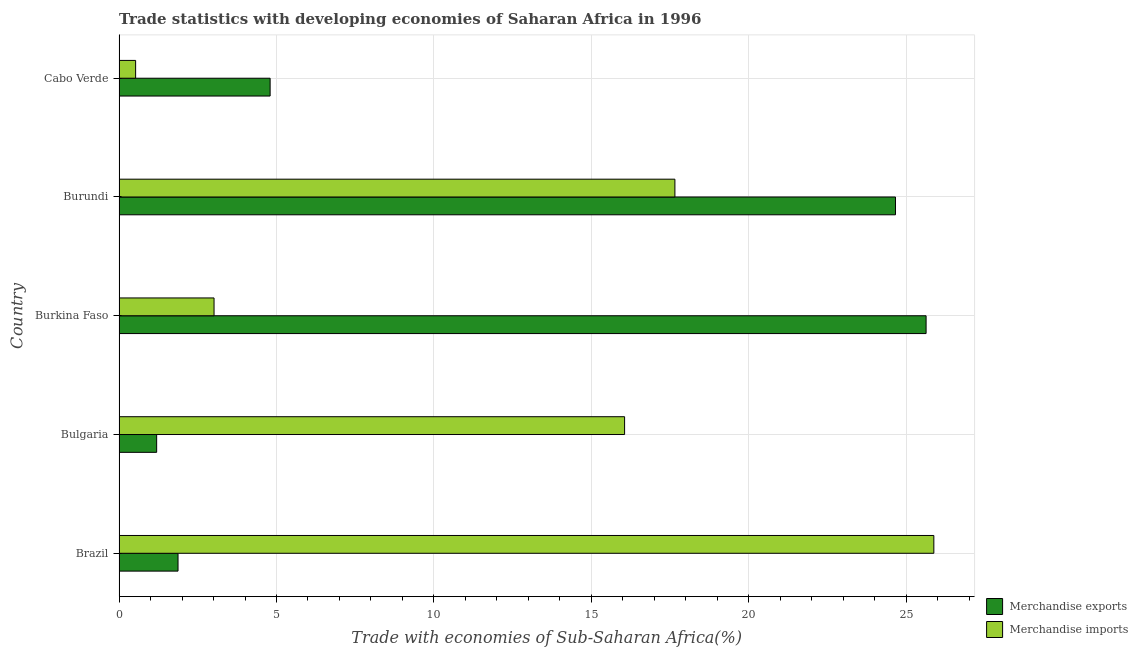How many different coloured bars are there?
Your answer should be compact. 2. What is the label of the 2nd group of bars from the top?
Your response must be concise. Burundi. What is the merchandise imports in Burundi?
Keep it short and to the point. 17.65. Across all countries, what is the maximum merchandise imports?
Keep it short and to the point. 25.87. Across all countries, what is the minimum merchandise exports?
Make the answer very short. 1.19. In which country was the merchandise exports maximum?
Provide a succinct answer. Burkina Faso. In which country was the merchandise imports minimum?
Offer a very short reply. Cabo Verde. What is the total merchandise imports in the graph?
Make the answer very short. 63.12. What is the difference between the merchandise imports in Burkina Faso and that in Cabo Verde?
Provide a succinct answer. 2.49. What is the difference between the merchandise imports in Burundi and the merchandise exports in Cabo Verde?
Keep it short and to the point. 12.85. What is the average merchandise exports per country?
Provide a succinct answer. 11.63. What is the difference between the merchandise imports and merchandise exports in Burkina Faso?
Your response must be concise. -22.61. In how many countries, is the merchandise exports greater than 4 %?
Give a very brief answer. 3. What is the ratio of the merchandise imports in Brazil to that in Burkina Faso?
Offer a terse response. 8.58. What is the difference between the highest and the second highest merchandise imports?
Ensure brevity in your answer.  8.22. What is the difference between the highest and the lowest merchandise exports?
Offer a very short reply. 24.43. In how many countries, is the merchandise imports greater than the average merchandise imports taken over all countries?
Provide a succinct answer. 3. How many bars are there?
Provide a short and direct response. 10. Are all the bars in the graph horizontal?
Ensure brevity in your answer.  Yes. Are the values on the major ticks of X-axis written in scientific E-notation?
Your answer should be compact. No. Does the graph contain any zero values?
Ensure brevity in your answer.  No. How are the legend labels stacked?
Ensure brevity in your answer.  Vertical. What is the title of the graph?
Your answer should be very brief. Trade statistics with developing economies of Saharan Africa in 1996. Does "Under-5(male)" appear as one of the legend labels in the graph?
Provide a short and direct response. No. What is the label or title of the X-axis?
Give a very brief answer. Trade with economies of Sub-Saharan Africa(%). What is the label or title of the Y-axis?
Offer a terse response. Country. What is the Trade with economies of Sub-Saharan Africa(%) in Merchandise exports in Brazil?
Your answer should be compact. 1.87. What is the Trade with economies of Sub-Saharan Africa(%) of Merchandise imports in Brazil?
Provide a short and direct response. 25.87. What is the Trade with economies of Sub-Saharan Africa(%) of Merchandise exports in Bulgaria?
Keep it short and to the point. 1.19. What is the Trade with economies of Sub-Saharan Africa(%) in Merchandise imports in Bulgaria?
Your response must be concise. 16.05. What is the Trade with economies of Sub-Saharan Africa(%) of Merchandise exports in Burkina Faso?
Give a very brief answer. 25.63. What is the Trade with economies of Sub-Saharan Africa(%) in Merchandise imports in Burkina Faso?
Make the answer very short. 3.02. What is the Trade with economies of Sub-Saharan Africa(%) in Merchandise exports in Burundi?
Keep it short and to the point. 24.66. What is the Trade with economies of Sub-Saharan Africa(%) of Merchandise imports in Burundi?
Keep it short and to the point. 17.65. What is the Trade with economies of Sub-Saharan Africa(%) in Merchandise exports in Cabo Verde?
Your answer should be compact. 4.8. What is the Trade with economies of Sub-Saharan Africa(%) of Merchandise imports in Cabo Verde?
Provide a succinct answer. 0.53. Across all countries, what is the maximum Trade with economies of Sub-Saharan Africa(%) in Merchandise exports?
Offer a very short reply. 25.63. Across all countries, what is the maximum Trade with economies of Sub-Saharan Africa(%) in Merchandise imports?
Offer a very short reply. 25.87. Across all countries, what is the minimum Trade with economies of Sub-Saharan Africa(%) of Merchandise exports?
Ensure brevity in your answer.  1.19. Across all countries, what is the minimum Trade with economies of Sub-Saharan Africa(%) in Merchandise imports?
Your answer should be very brief. 0.53. What is the total Trade with economies of Sub-Saharan Africa(%) in Merchandise exports in the graph?
Ensure brevity in your answer.  58.15. What is the total Trade with economies of Sub-Saharan Africa(%) of Merchandise imports in the graph?
Make the answer very short. 63.12. What is the difference between the Trade with economies of Sub-Saharan Africa(%) in Merchandise exports in Brazil and that in Bulgaria?
Provide a short and direct response. 0.68. What is the difference between the Trade with economies of Sub-Saharan Africa(%) of Merchandise imports in Brazil and that in Bulgaria?
Your response must be concise. 9.82. What is the difference between the Trade with economies of Sub-Saharan Africa(%) of Merchandise exports in Brazil and that in Burkina Faso?
Offer a very short reply. -23.76. What is the difference between the Trade with economies of Sub-Saharan Africa(%) in Merchandise imports in Brazil and that in Burkina Faso?
Make the answer very short. 22.86. What is the difference between the Trade with economies of Sub-Saharan Africa(%) in Merchandise exports in Brazil and that in Burundi?
Your answer should be compact. -22.78. What is the difference between the Trade with economies of Sub-Saharan Africa(%) in Merchandise imports in Brazil and that in Burundi?
Your answer should be compact. 8.22. What is the difference between the Trade with economies of Sub-Saharan Africa(%) of Merchandise exports in Brazil and that in Cabo Verde?
Your answer should be very brief. -2.92. What is the difference between the Trade with economies of Sub-Saharan Africa(%) of Merchandise imports in Brazil and that in Cabo Verde?
Give a very brief answer. 25.35. What is the difference between the Trade with economies of Sub-Saharan Africa(%) in Merchandise exports in Bulgaria and that in Burkina Faso?
Keep it short and to the point. -24.43. What is the difference between the Trade with economies of Sub-Saharan Africa(%) in Merchandise imports in Bulgaria and that in Burkina Faso?
Offer a very short reply. 13.04. What is the difference between the Trade with economies of Sub-Saharan Africa(%) in Merchandise exports in Bulgaria and that in Burundi?
Give a very brief answer. -23.46. What is the difference between the Trade with economies of Sub-Saharan Africa(%) in Merchandise imports in Bulgaria and that in Burundi?
Provide a succinct answer. -1.6. What is the difference between the Trade with economies of Sub-Saharan Africa(%) in Merchandise exports in Bulgaria and that in Cabo Verde?
Offer a terse response. -3.6. What is the difference between the Trade with economies of Sub-Saharan Africa(%) of Merchandise imports in Bulgaria and that in Cabo Verde?
Your answer should be compact. 15.53. What is the difference between the Trade with economies of Sub-Saharan Africa(%) of Merchandise exports in Burkina Faso and that in Burundi?
Ensure brevity in your answer.  0.97. What is the difference between the Trade with economies of Sub-Saharan Africa(%) in Merchandise imports in Burkina Faso and that in Burundi?
Give a very brief answer. -14.64. What is the difference between the Trade with economies of Sub-Saharan Africa(%) in Merchandise exports in Burkina Faso and that in Cabo Verde?
Your answer should be very brief. 20.83. What is the difference between the Trade with economies of Sub-Saharan Africa(%) of Merchandise imports in Burkina Faso and that in Cabo Verde?
Provide a short and direct response. 2.49. What is the difference between the Trade with economies of Sub-Saharan Africa(%) in Merchandise exports in Burundi and that in Cabo Verde?
Your answer should be compact. 19.86. What is the difference between the Trade with economies of Sub-Saharan Africa(%) of Merchandise imports in Burundi and that in Cabo Verde?
Give a very brief answer. 17.13. What is the difference between the Trade with economies of Sub-Saharan Africa(%) of Merchandise exports in Brazil and the Trade with economies of Sub-Saharan Africa(%) of Merchandise imports in Bulgaria?
Ensure brevity in your answer.  -14.18. What is the difference between the Trade with economies of Sub-Saharan Africa(%) in Merchandise exports in Brazil and the Trade with economies of Sub-Saharan Africa(%) in Merchandise imports in Burkina Faso?
Ensure brevity in your answer.  -1.14. What is the difference between the Trade with economies of Sub-Saharan Africa(%) in Merchandise exports in Brazil and the Trade with economies of Sub-Saharan Africa(%) in Merchandise imports in Burundi?
Give a very brief answer. -15.78. What is the difference between the Trade with economies of Sub-Saharan Africa(%) of Merchandise exports in Brazil and the Trade with economies of Sub-Saharan Africa(%) of Merchandise imports in Cabo Verde?
Ensure brevity in your answer.  1.35. What is the difference between the Trade with economies of Sub-Saharan Africa(%) in Merchandise exports in Bulgaria and the Trade with economies of Sub-Saharan Africa(%) in Merchandise imports in Burkina Faso?
Your answer should be compact. -1.82. What is the difference between the Trade with economies of Sub-Saharan Africa(%) of Merchandise exports in Bulgaria and the Trade with economies of Sub-Saharan Africa(%) of Merchandise imports in Burundi?
Keep it short and to the point. -16.46. What is the difference between the Trade with economies of Sub-Saharan Africa(%) in Merchandise exports in Bulgaria and the Trade with economies of Sub-Saharan Africa(%) in Merchandise imports in Cabo Verde?
Provide a succinct answer. 0.67. What is the difference between the Trade with economies of Sub-Saharan Africa(%) of Merchandise exports in Burkina Faso and the Trade with economies of Sub-Saharan Africa(%) of Merchandise imports in Burundi?
Keep it short and to the point. 7.98. What is the difference between the Trade with economies of Sub-Saharan Africa(%) of Merchandise exports in Burkina Faso and the Trade with economies of Sub-Saharan Africa(%) of Merchandise imports in Cabo Verde?
Make the answer very short. 25.1. What is the difference between the Trade with economies of Sub-Saharan Africa(%) of Merchandise exports in Burundi and the Trade with economies of Sub-Saharan Africa(%) of Merchandise imports in Cabo Verde?
Give a very brief answer. 24.13. What is the average Trade with economies of Sub-Saharan Africa(%) in Merchandise exports per country?
Ensure brevity in your answer.  11.63. What is the average Trade with economies of Sub-Saharan Africa(%) in Merchandise imports per country?
Your answer should be very brief. 12.62. What is the difference between the Trade with economies of Sub-Saharan Africa(%) of Merchandise exports and Trade with economies of Sub-Saharan Africa(%) of Merchandise imports in Brazil?
Your response must be concise. -24. What is the difference between the Trade with economies of Sub-Saharan Africa(%) in Merchandise exports and Trade with economies of Sub-Saharan Africa(%) in Merchandise imports in Bulgaria?
Give a very brief answer. -14.86. What is the difference between the Trade with economies of Sub-Saharan Africa(%) in Merchandise exports and Trade with economies of Sub-Saharan Africa(%) in Merchandise imports in Burkina Faso?
Offer a very short reply. 22.61. What is the difference between the Trade with economies of Sub-Saharan Africa(%) in Merchandise exports and Trade with economies of Sub-Saharan Africa(%) in Merchandise imports in Burundi?
Keep it short and to the point. 7. What is the difference between the Trade with economies of Sub-Saharan Africa(%) in Merchandise exports and Trade with economies of Sub-Saharan Africa(%) in Merchandise imports in Cabo Verde?
Your answer should be very brief. 4.27. What is the ratio of the Trade with economies of Sub-Saharan Africa(%) of Merchandise exports in Brazil to that in Bulgaria?
Give a very brief answer. 1.57. What is the ratio of the Trade with economies of Sub-Saharan Africa(%) in Merchandise imports in Brazil to that in Bulgaria?
Provide a succinct answer. 1.61. What is the ratio of the Trade with economies of Sub-Saharan Africa(%) in Merchandise exports in Brazil to that in Burkina Faso?
Keep it short and to the point. 0.07. What is the ratio of the Trade with economies of Sub-Saharan Africa(%) in Merchandise imports in Brazil to that in Burkina Faso?
Your answer should be compact. 8.58. What is the ratio of the Trade with economies of Sub-Saharan Africa(%) in Merchandise exports in Brazil to that in Burundi?
Your response must be concise. 0.08. What is the ratio of the Trade with economies of Sub-Saharan Africa(%) in Merchandise imports in Brazil to that in Burundi?
Keep it short and to the point. 1.47. What is the ratio of the Trade with economies of Sub-Saharan Africa(%) of Merchandise exports in Brazil to that in Cabo Verde?
Offer a terse response. 0.39. What is the ratio of the Trade with economies of Sub-Saharan Africa(%) of Merchandise imports in Brazil to that in Cabo Verde?
Your response must be concise. 49.15. What is the ratio of the Trade with economies of Sub-Saharan Africa(%) in Merchandise exports in Bulgaria to that in Burkina Faso?
Make the answer very short. 0.05. What is the ratio of the Trade with economies of Sub-Saharan Africa(%) in Merchandise imports in Bulgaria to that in Burkina Faso?
Your response must be concise. 5.32. What is the ratio of the Trade with economies of Sub-Saharan Africa(%) of Merchandise exports in Bulgaria to that in Burundi?
Make the answer very short. 0.05. What is the ratio of the Trade with economies of Sub-Saharan Africa(%) in Merchandise imports in Bulgaria to that in Burundi?
Provide a short and direct response. 0.91. What is the ratio of the Trade with economies of Sub-Saharan Africa(%) in Merchandise exports in Bulgaria to that in Cabo Verde?
Make the answer very short. 0.25. What is the ratio of the Trade with economies of Sub-Saharan Africa(%) of Merchandise imports in Bulgaria to that in Cabo Verde?
Keep it short and to the point. 30.5. What is the ratio of the Trade with economies of Sub-Saharan Africa(%) in Merchandise exports in Burkina Faso to that in Burundi?
Provide a succinct answer. 1.04. What is the ratio of the Trade with economies of Sub-Saharan Africa(%) of Merchandise imports in Burkina Faso to that in Burundi?
Ensure brevity in your answer.  0.17. What is the ratio of the Trade with economies of Sub-Saharan Africa(%) in Merchandise exports in Burkina Faso to that in Cabo Verde?
Your answer should be compact. 5.34. What is the ratio of the Trade with economies of Sub-Saharan Africa(%) of Merchandise imports in Burkina Faso to that in Cabo Verde?
Make the answer very short. 5.73. What is the ratio of the Trade with economies of Sub-Saharan Africa(%) of Merchandise exports in Burundi to that in Cabo Verde?
Your answer should be very brief. 5.14. What is the ratio of the Trade with economies of Sub-Saharan Africa(%) of Merchandise imports in Burundi to that in Cabo Verde?
Offer a terse response. 33.53. What is the difference between the highest and the second highest Trade with economies of Sub-Saharan Africa(%) in Merchandise exports?
Provide a succinct answer. 0.97. What is the difference between the highest and the second highest Trade with economies of Sub-Saharan Africa(%) of Merchandise imports?
Your answer should be very brief. 8.22. What is the difference between the highest and the lowest Trade with economies of Sub-Saharan Africa(%) of Merchandise exports?
Offer a terse response. 24.43. What is the difference between the highest and the lowest Trade with economies of Sub-Saharan Africa(%) in Merchandise imports?
Your answer should be compact. 25.35. 